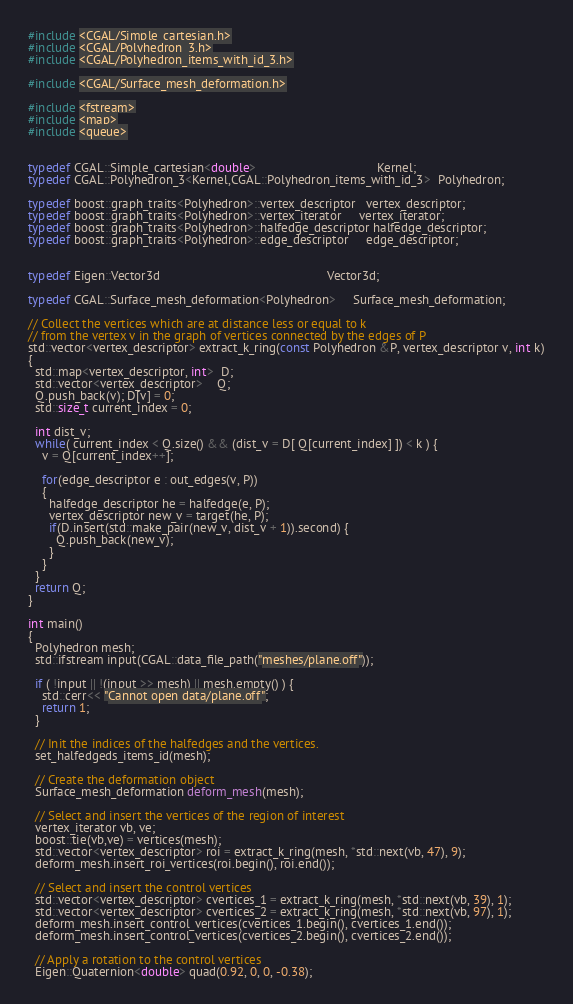Convert code to text. <code><loc_0><loc_0><loc_500><loc_500><_C++_>#include <CGAL/Simple_cartesian.h>
#include <CGAL/Polyhedron_3.h>
#include <CGAL/Polyhedron_items_with_id_3.h>

#include <CGAL/Surface_mesh_deformation.h>

#include <fstream>
#include <map>
#include <queue>


typedef CGAL::Simple_cartesian<double>                                   Kernel;
typedef CGAL::Polyhedron_3<Kernel,CGAL::Polyhedron_items_with_id_3>  Polyhedron;

typedef boost::graph_traits<Polyhedron>::vertex_descriptor   vertex_descriptor;
typedef boost::graph_traits<Polyhedron>::vertex_iterator     vertex_iterator;
typedef boost::graph_traits<Polyhedron>::halfedge_descriptor halfedge_descriptor;
typedef boost::graph_traits<Polyhedron>::edge_descriptor     edge_descriptor;


typedef Eigen::Vector3d                                                Vector3d;

typedef CGAL::Surface_mesh_deformation<Polyhedron>     Surface_mesh_deformation;

// Collect the vertices which are at distance less or equal to k
// from the vertex v in the graph of vertices connected by the edges of P
std::vector<vertex_descriptor> extract_k_ring(const Polyhedron &P, vertex_descriptor v, int k)
{
  std::map<vertex_descriptor, int>  D;
  std::vector<vertex_descriptor>    Q;
  Q.push_back(v); D[v] = 0;
  std::size_t current_index = 0;

  int dist_v;
  while( current_index < Q.size() && (dist_v = D[ Q[current_index] ]) < k ) {
    v = Q[current_index++];

    for(edge_descriptor e : out_edges(v, P))
    {
      halfedge_descriptor he = halfedge(e, P);
      vertex_descriptor new_v = target(he, P);
      if(D.insert(std::make_pair(new_v, dist_v + 1)).second) {
        Q.push_back(new_v);
      }
    }
  }
  return Q;
}

int main()
{
  Polyhedron mesh;
  std::ifstream input(CGAL::data_file_path("meshes/plane.off"));

  if ( !input || !(input >> mesh) || mesh.empty() ) {
    std::cerr<< "Cannot open data/plane.off";
    return 1;
  }

  // Init the indices of the halfedges and the vertices.
  set_halfedgeds_items_id(mesh);

  // Create the deformation object
  Surface_mesh_deformation deform_mesh(mesh);

  // Select and insert the vertices of the region of interest
  vertex_iterator vb, ve;
  boost::tie(vb,ve) = vertices(mesh);
  std::vector<vertex_descriptor> roi = extract_k_ring(mesh, *std::next(vb, 47), 9);
  deform_mesh.insert_roi_vertices(roi.begin(), roi.end());

  // Select and insert the control vertices
  std::vector<vertex_descriptor> cvertices_1 = extract_k_ring(mesh, *std::next(vb, 39), 1);
  std::vector<vertex_descriptor> cvertices_2 = extract_k_ring(mesh, *std::next(vb, 97), 1);
  deform_mesh.insert_control_vertices(cvertices_1.begin(), cvertices_1.end());
  deform_mesh.insert_control_vertices(cvertices_2.begin(), cvertices_2.end());

  // Apply a rotation to the control vertices
  Eigen::Quaternion<double> quad(0.92, 0, 0, -0.38);</code> 